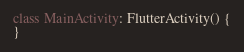<code> <loc_0><loc_0><loc_500><loc_500><_Kotlin_>
class MainActivity: FlutterActivity() {
}
</code> 